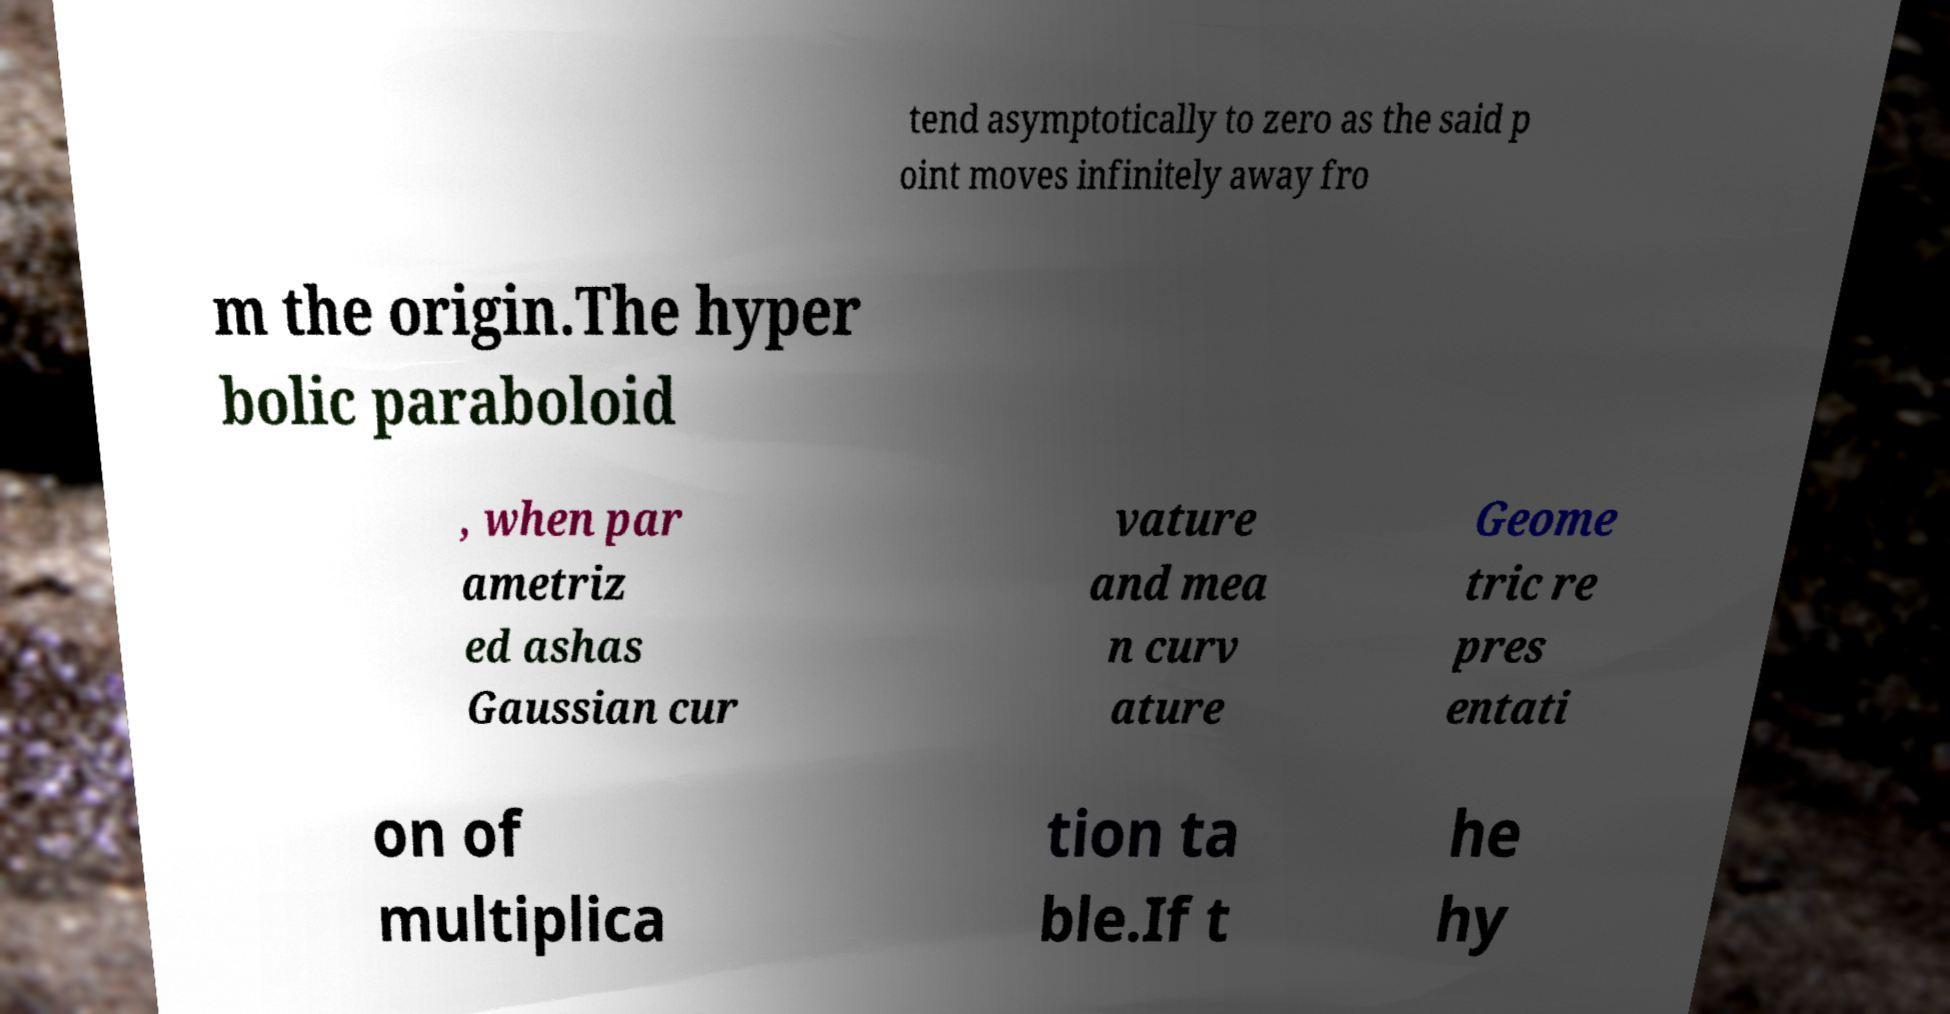For documentation purposes, I need the text within this image transcribed. Could you provide that? tend asymptotically to zero as the said p oint moves infinitely away fro m the origin.The hyper bolic paraboloid , when par ametriz ed ashas Gaussian cur vature and mea n curv ature Geome tric re pres entati on of multiplica tion ta ble.If t he hy 